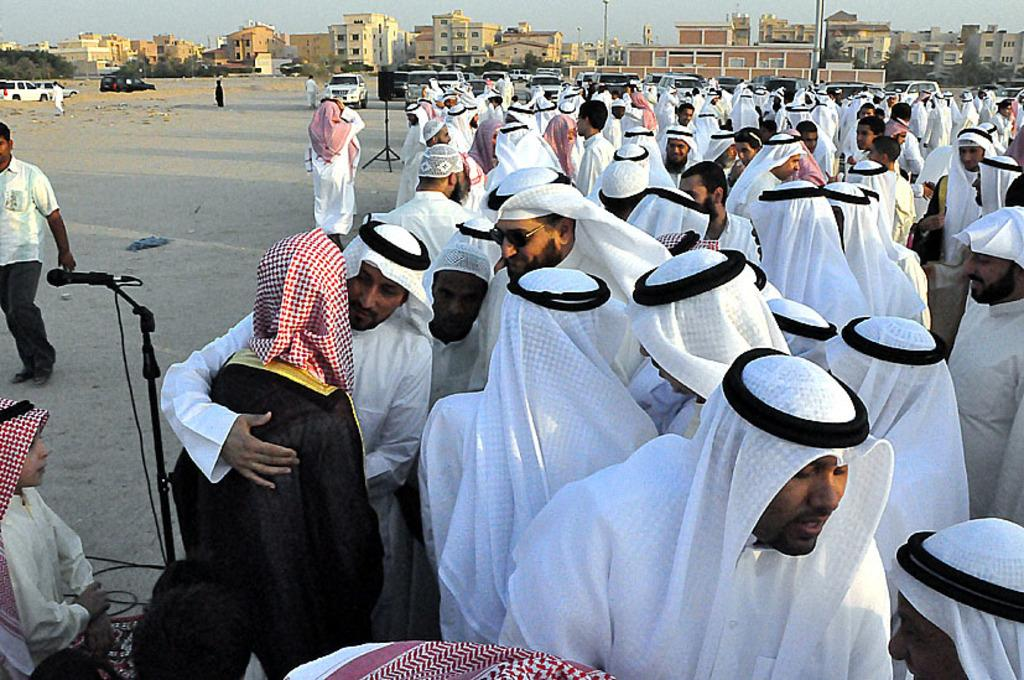What is the main subject in the foreground of the image? There is a group of men in the foreground of the image. What can be seen behind the group of men? Cars are visible behind the group of men. What is visible in the background of the image? There are buildings in the background of the image. What type of hospital can be seen in the image? There is no hospital present in the image. What form does the wrench take in the image? There is no wrench present in the image. 